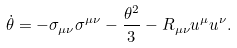<formula> <loc_0><loc_0><loc_500><loc_500>\dot { \theta } = - \sigma _ { \mu \nu } \sigma ^ { \mu \nu } - \frac { \theta ^ { 2 } } { 3 } - R _ { \mu \nu } u ^ { \mu } u ^ { \nu } .</formula> 